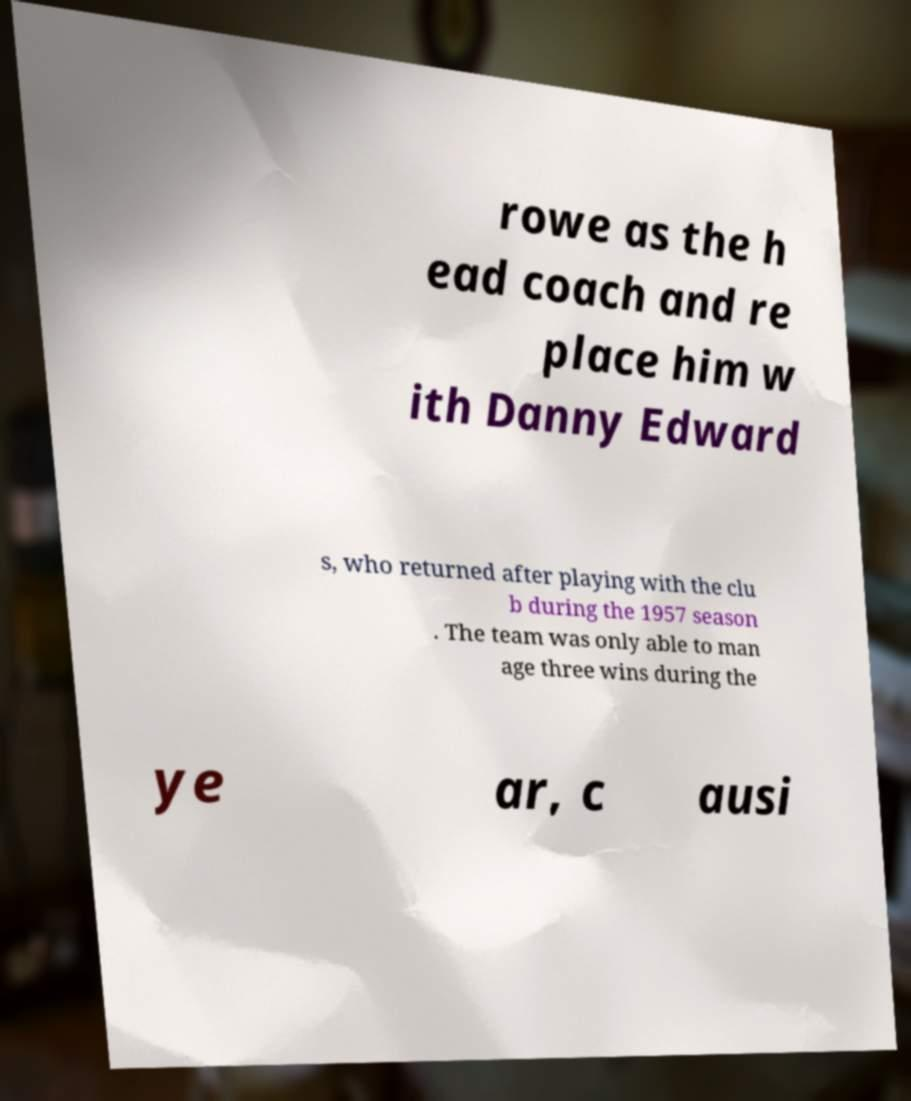For documentation purposes, I need the text within this image transcribed. Could you provide that? rowe as the h ead coach and re place him w ith Danny Edward s, who returned after playing with the clu b during the 1957 season . The team was only able to man age three wins during the ye ar, c ausi 